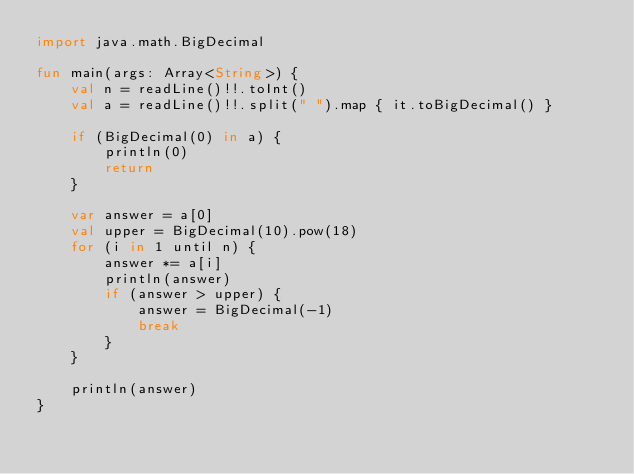Convert code to text. <code><loc_0><loc_0><loc_500><loc_500><_Kotlin_>import java.math.BigDecimal

fun main(args: Array<String>) {
    val n = readLine()!!.toInt()
    val a = readLine()!!.split(" ").map { it.toBigDecimal() }

    if (BigDecimal(0) in a) {
        println(0)
        return
    }

    var answer = a[0]
    val upper = BigDecimal(10).pow(18)
    for (i in 1 until n) {
        answer *= a[i]
        println(answer)
        if (answer > upper) {
            answer = BigDecimal(-1)
            break
        }
    }

    println(answer)
}
</code> 